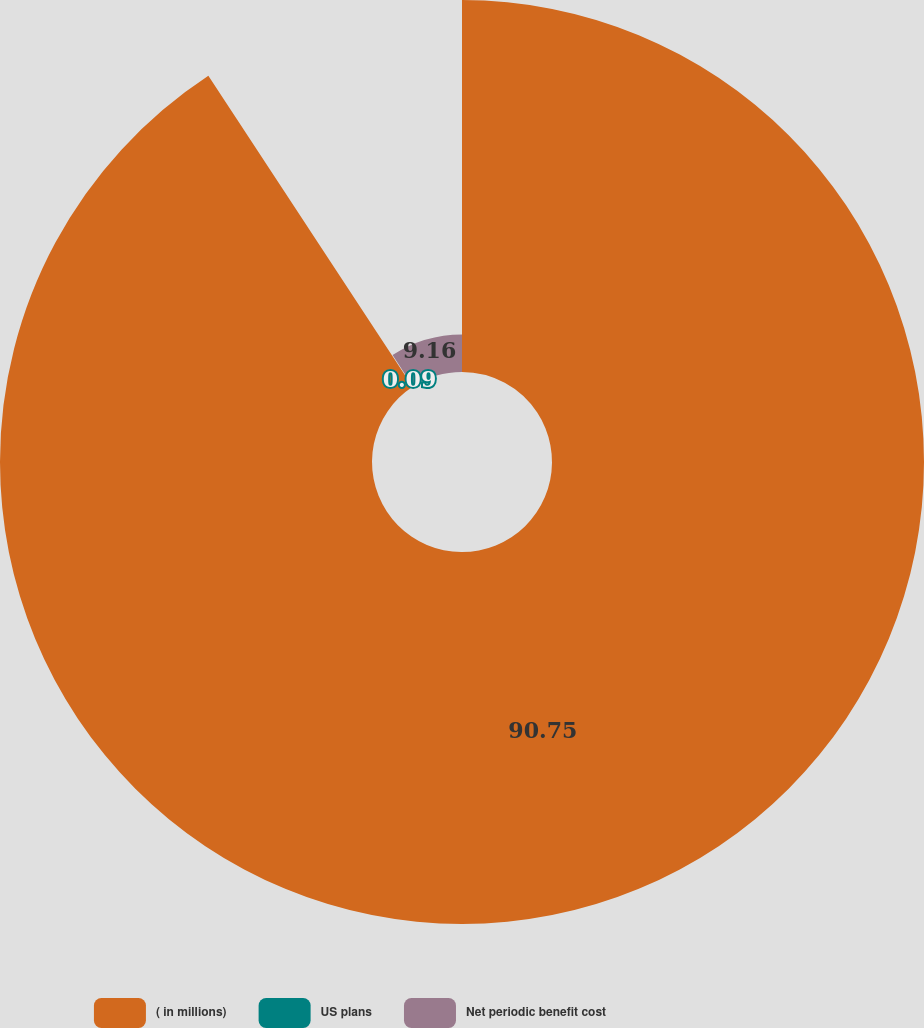<chart> <loc_0><loc_0><loc_500><loc_500><pie_chart><fcel>( in millions)<fcel>US plans<fcel>Net periodic benefit cost<nl><fcel>90.75%<fcel>0.09%<fcel>9.16%<nl></chart> 